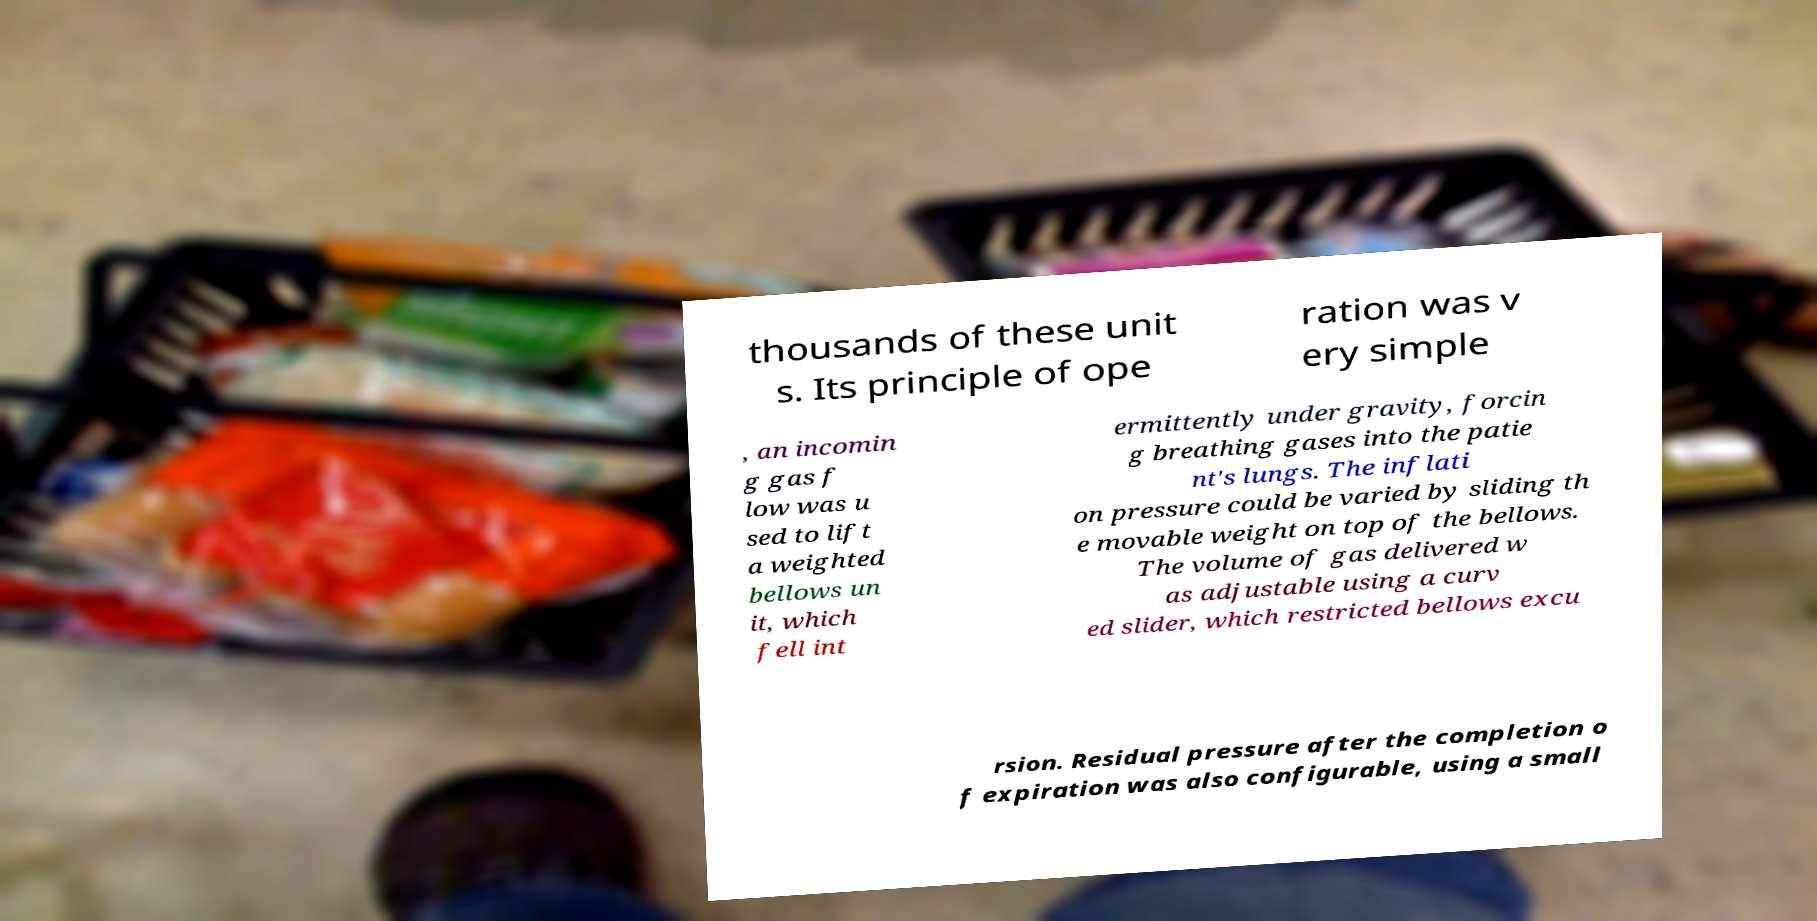Could you extract and type out the text from this image? thousands of these unit s. Its principle of ope ration was v ery simple , an incomin g gas f low was u sed to lift a weighted bellows un it, which fell int ermittently under gravity, forcin g breathing gases into the patie nt's lungs. The inflati on pressure could be varied by sliding th e movable weight on top of the bellows. The volume of gas delivered w as adjustable using a curv ed slider, which restricted bellows excu rsion. Residual pressure after the completion o f expiration was also configurable, using a small 